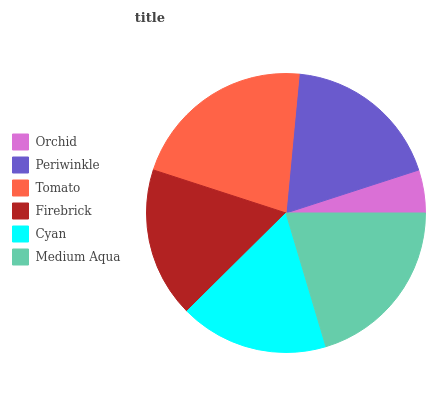Is Orchid the minimum?
Answer yes or no. Yes. Is Tomato the maximum?
Answer yes or no. Yes. Is Periwinkle the minimum?
Answer yes or no. No. Is Periwinkle the maximum?
Answer yes or no. No. Is Periwinkle greater than Orchid?
Answer yes or no. Yes. Is Orchid less than Periwinkle?
Answer yes or no. Yes. Is Orchid greater than Periwinkle?
Answer yes or no. No. Is Periwinkle less than Orchid?
Answer yes or no. No. Is Periwinkle the high median?
Answer yes or no. Yes. Is Firebrick the low median?
Answer yes or no. Yes. Is Firebrick the high median?
Answer yes or no. No. Is Medium Aqua the low median?
Answer yes or no. No. 